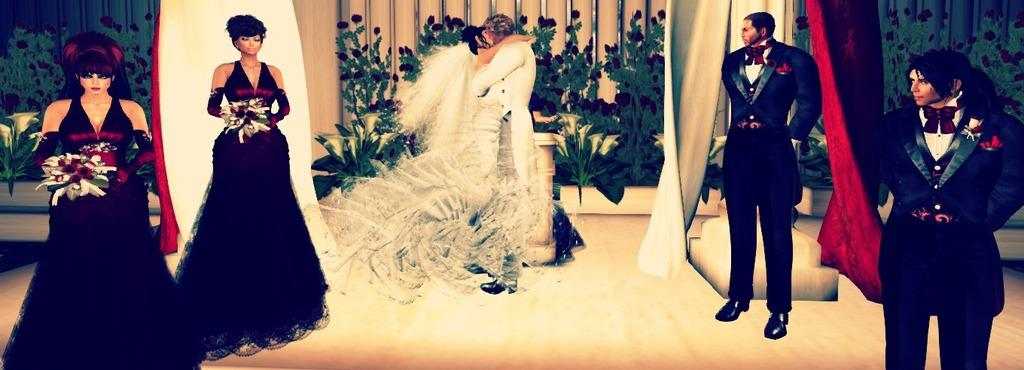What type of surface is visible in the image? The image contains a floor. Can you describe the people in the image? There are people in the image. What other living organisms can be seen in the image? There are plants and flowers in the image. What type of window treatment is present in the image? There are curtains in the image. What is the background of the image made of? There is a wall in the image. What type of soup is being served in the image? There is no soup present in the image. Can you describe the donkey in the image? There is no donkey present in the image. 